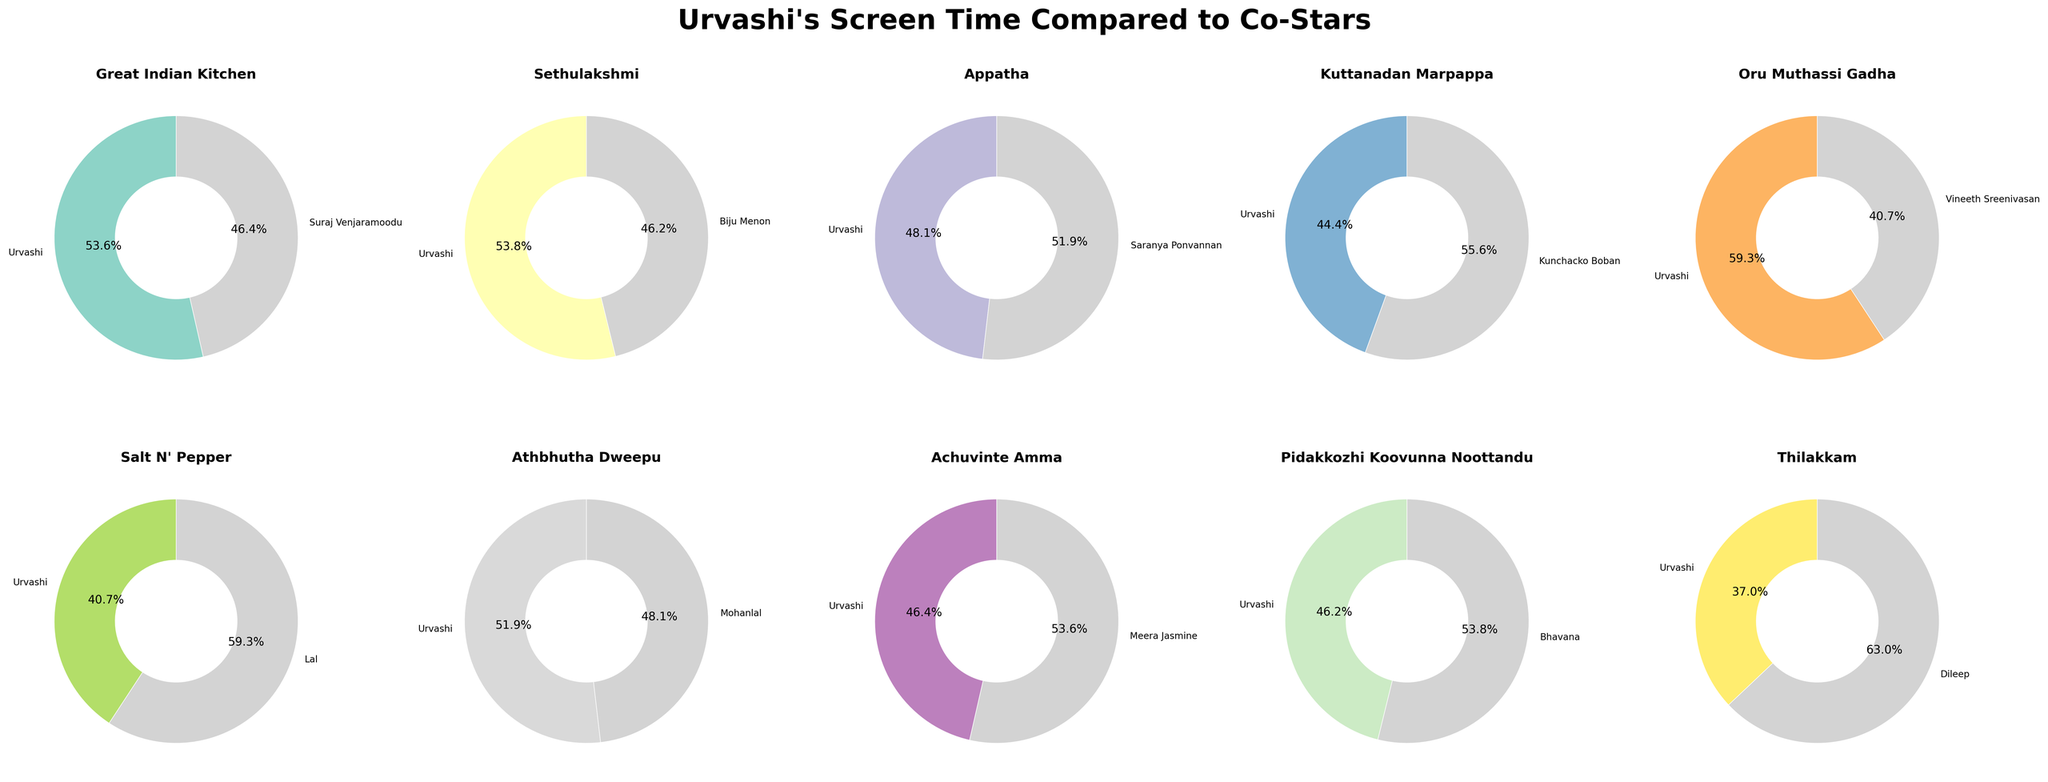What film has Urvashi seen with her smallest screen time? Observe the film titles and screen times, Urvashi's smallest screen time is 50 minutes in "Thilakkam".
Answer: "Thilakkam" What movie shows the greatest difference in screen time between Urvashi and her co-star? Compare the absolute differences in screen time for each film; the greatest difference is between Urvashi (50) and Dileep (85) in "Thilakkam", with an absolute difference of 35 minutes.
Answer: "Thilakkam" Is Urvashi's screen time more or less than her co-star in "Appatha"? Look at "Appatha" film; Urvashi's screen time is 65 minutes, whereas Saranya Ponvannan's is 70 minutes.
Answer: Less Which film features nearly equal screen times for Urvashi and her co-star? Identify films where screen times are close; "Great Indian Kitchen" (75 vs. 65), "Sethulakshmi" (70 vs. 60), and "Athbhutha Dweepu" (70 vs. 65) are close but "Athbhutha Dweepu" (70 vs. 65) is almost the same screen time.
Answer: "Athbhutha Dweepu" What's the average screen time for Urvashi across all films? Sum Urvashi's screen times (75 + 70 + 65 + 60 + 80 + 55 + 70 + 65 + 60 + 50 = 650) and divide by 10 (= total films), so the average is 650/10
Answer: 65 Who had more screen time, Urvashi or Suraj Venjaramoodu in "Great Indian Kitchen"? For "Great Indian Kitchen", Urvashi had 75 minutes, Suraj Venjaramoodu had 65 minutes.
Answer: Urvashi Which film has the highest screen time for Urvashi? Observe the plot for the highest value, Urvashi's maximum screen time is 80 minutes in "Oru Muthassi Gadha".
Answer: "Oru Muthassi Gadha" Find the two films where Urvashi and her co-star’s screen times are in stark contrast. Look for where the difference is conspicuous, "Thilakkam" (50 vs 85) and "Salt N' Pepper" (55 vs 80).
Answer: "Thilakkam" and "Salt N' Pepper" Compute the average screen time of Urvashi's co-stars across all films. Sum all co-stars' screen times (65 + 60 + 70 + 75 + 55 + 80 + 65 + 75 + 70 + 85 = 700) and divide by 10 (total films), so the average is 700/10
Answer: 70 Who had the least screen time in "Salt N' Pepper"? Look directly at the plot: Urvashi (55 minutes) vs. Lal (80 minutes).
Answer: Urvashi 